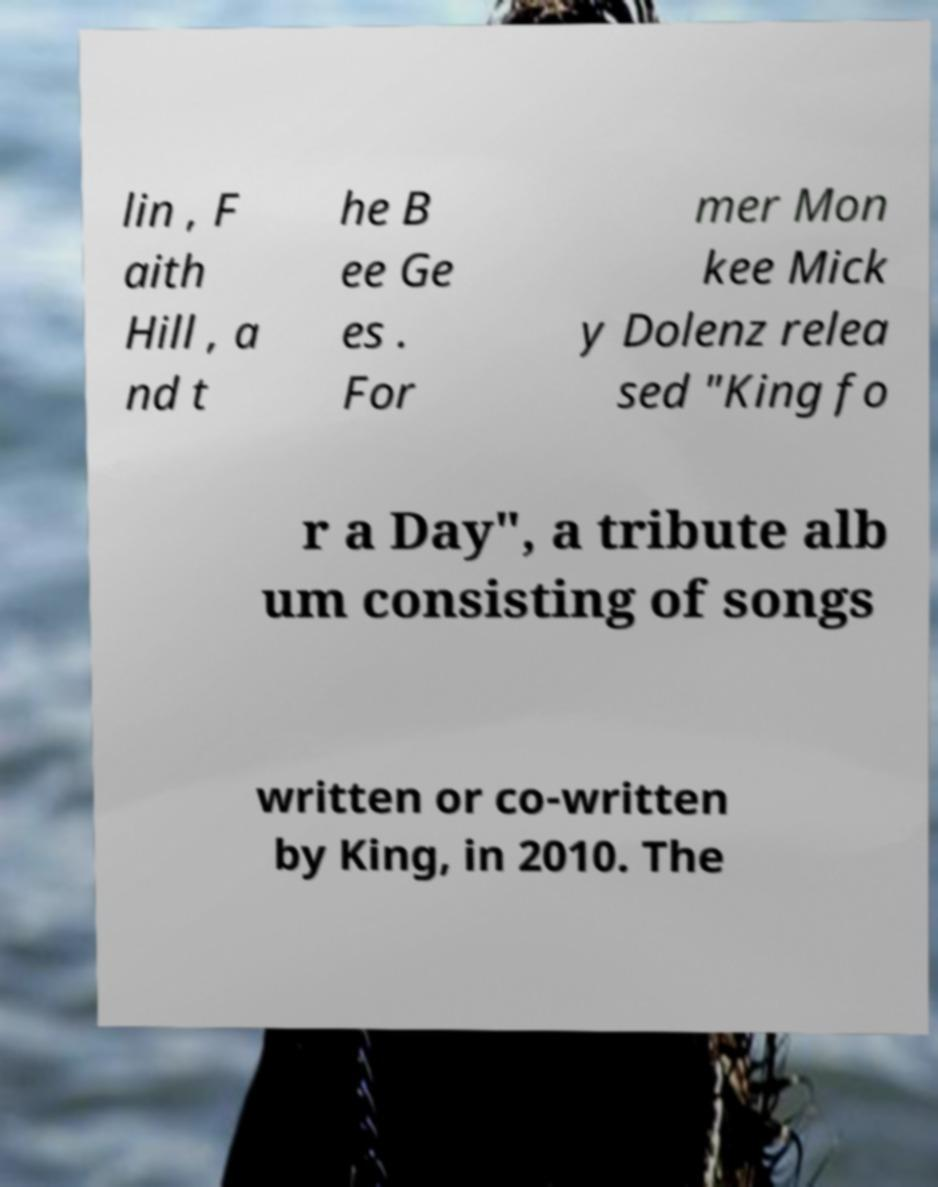For documentation purposes, I need the text within this image transcribed. Could you provide that? lin , F aith Hill , a nd t he B ee Ge es . For mer Mon kee Mick y Dolenz relea sed "King fo r a Day", a tribute alb um consisting of songs written or co-written by King, in 2010. The 